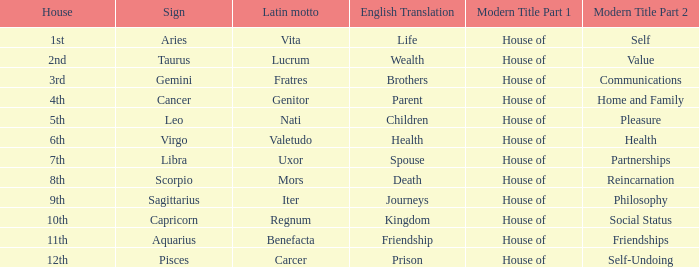What is the modern house title of the 1st house? House of Self. 